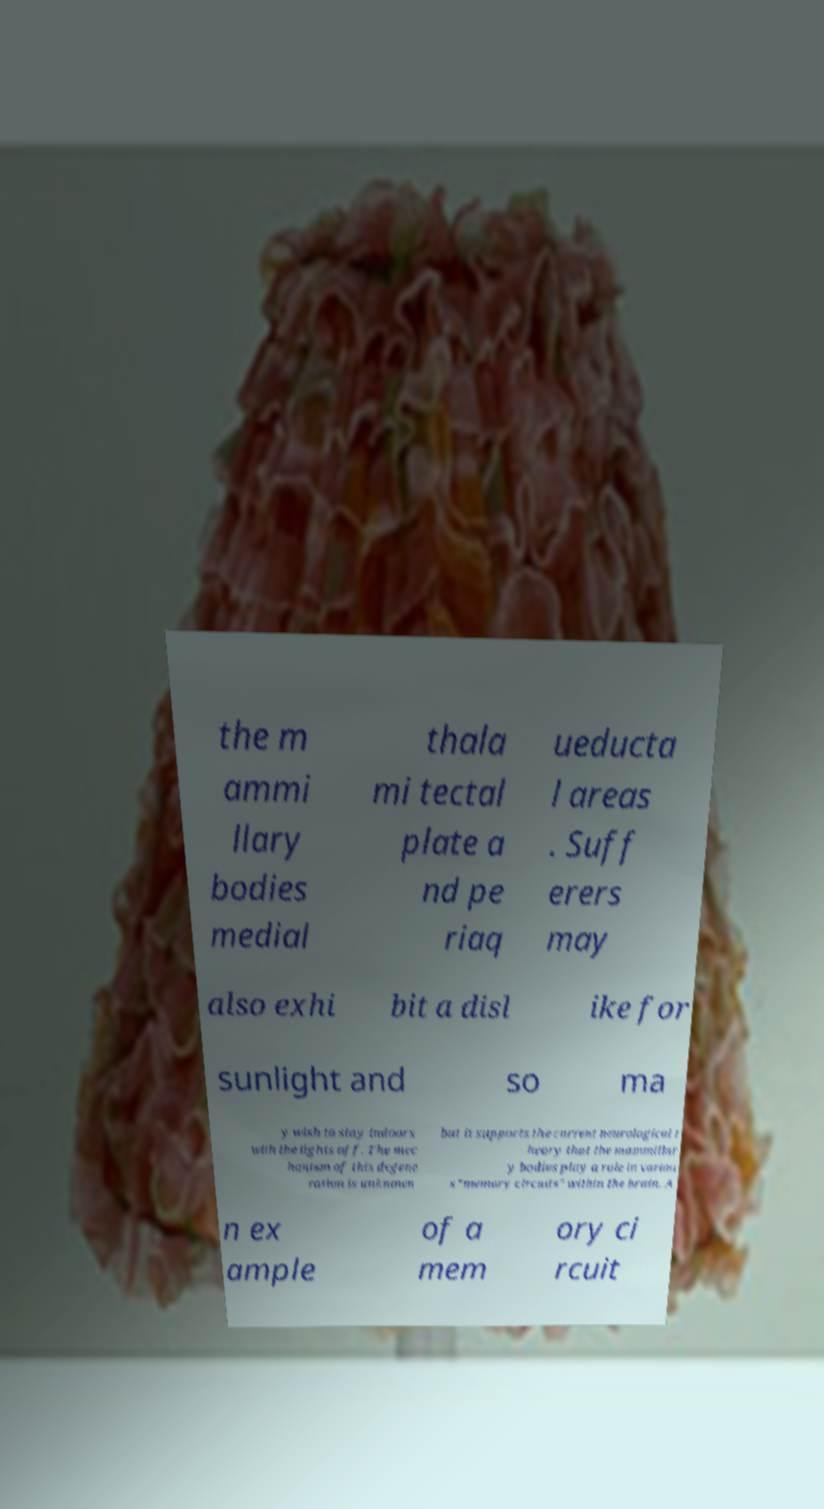What messages or text are displayed in this image? I need them in a readable, typed format. the m ammi llary bodies medial thala mi tectal plate a nd pe riaq ueducta l areas . Suff erers may also exhi bit a disl ike for sunlight and so ma y wish to stay indoors with the lights off. The mec hanism of this degene ration is unknown but it supports the current neurological t heory that the mammillar y bodies play a role in variou s "memory circuits" within the brain. A n ex ample of a mem ory ci rcuit 